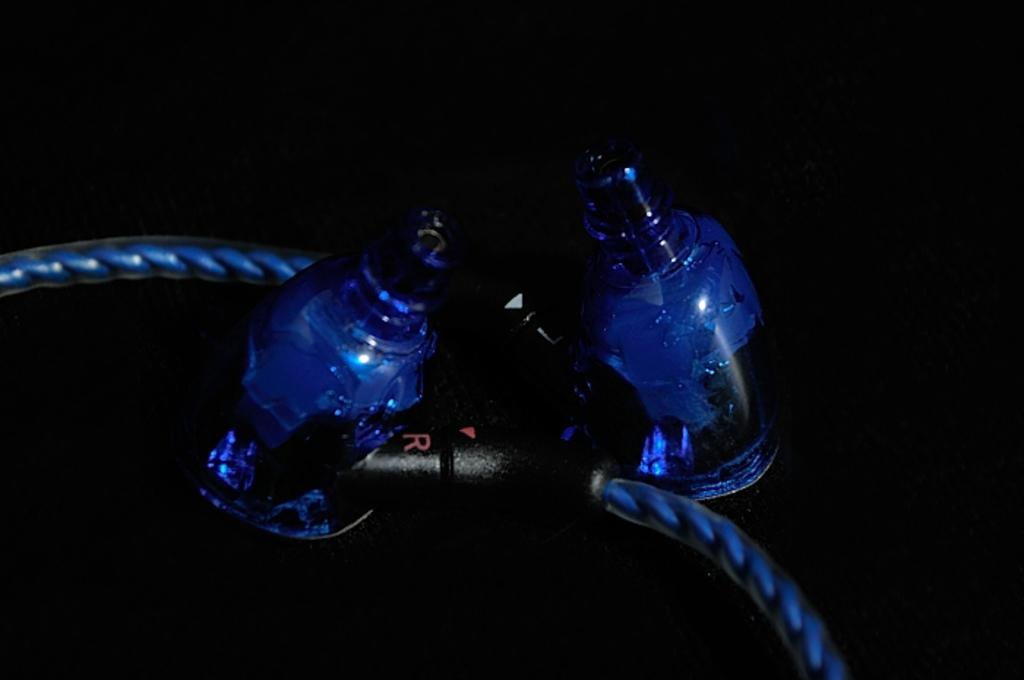<image>
Provide a brief description of the given image. Wires connect a dark attachment with neon blue and a red R is on the connector piece. 